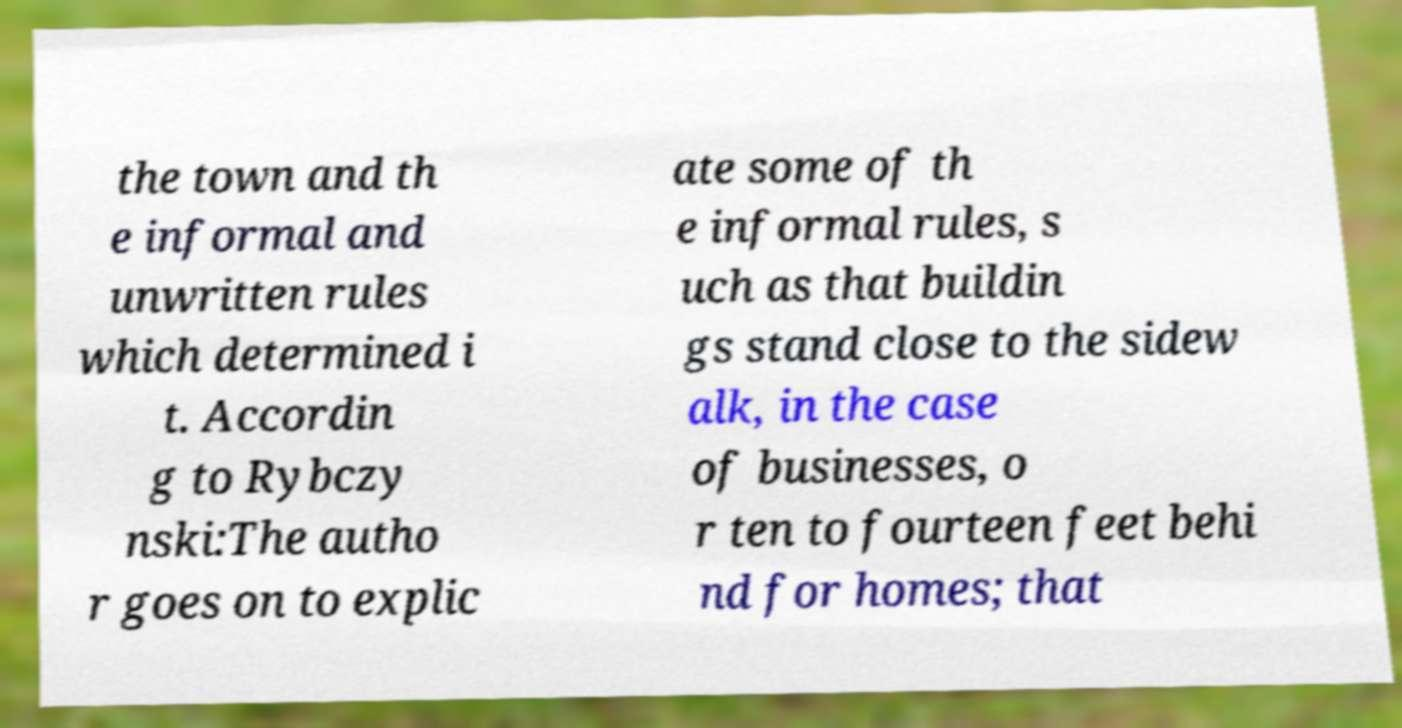Could you assist in decoding the text presented in this image and type it out clearly? the town and th e informal and unwritten rules which determined i t. Accordin g to Rybczy nski:The autho r goes on to explic ate some of th e informal rules, s uch as that buildin gs stand close to the sidew alk, in the case of businesses, o r ten to fourteen feet behi nd for homes; that 